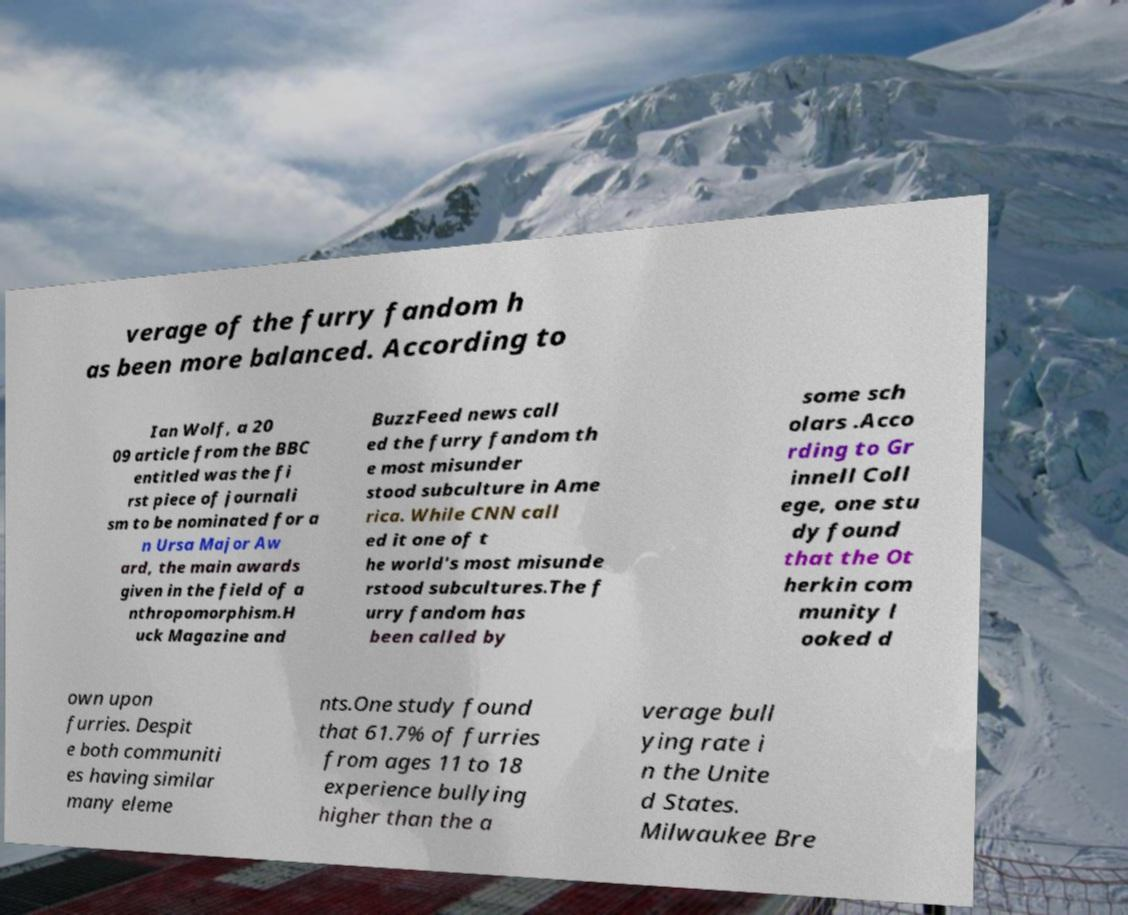I need the written content from this picture converted into text. Can you do that? verage of the furry fandom h as been more balanced. According to Ian Wolf, a 20 09 article from the BBC entitled was the fi rst piece of journali sm to be nominated for a n Ursa Major Aw ard, the main awards given in the field of a nthropomorphism.H uck Magazine and BuzzFeed news call ed the furry fandom th e most misunder stood subculture in Ame rica. While CNN call ed it one of t he world's most misunde rstood subcultures.The f urry fandom has been called by some sch olars .Acco rding to Gr innell Coll ege, one stu dy found that the Ot herkin com munity l ooked d own upon furries. Despit e both communiti es having similar many eleme nts.One study found that 61.7% of furries from ages 11 to 18 experience bullying higher than the a verage bull ying rate i n the Unite d States. Milwaukee Bre 